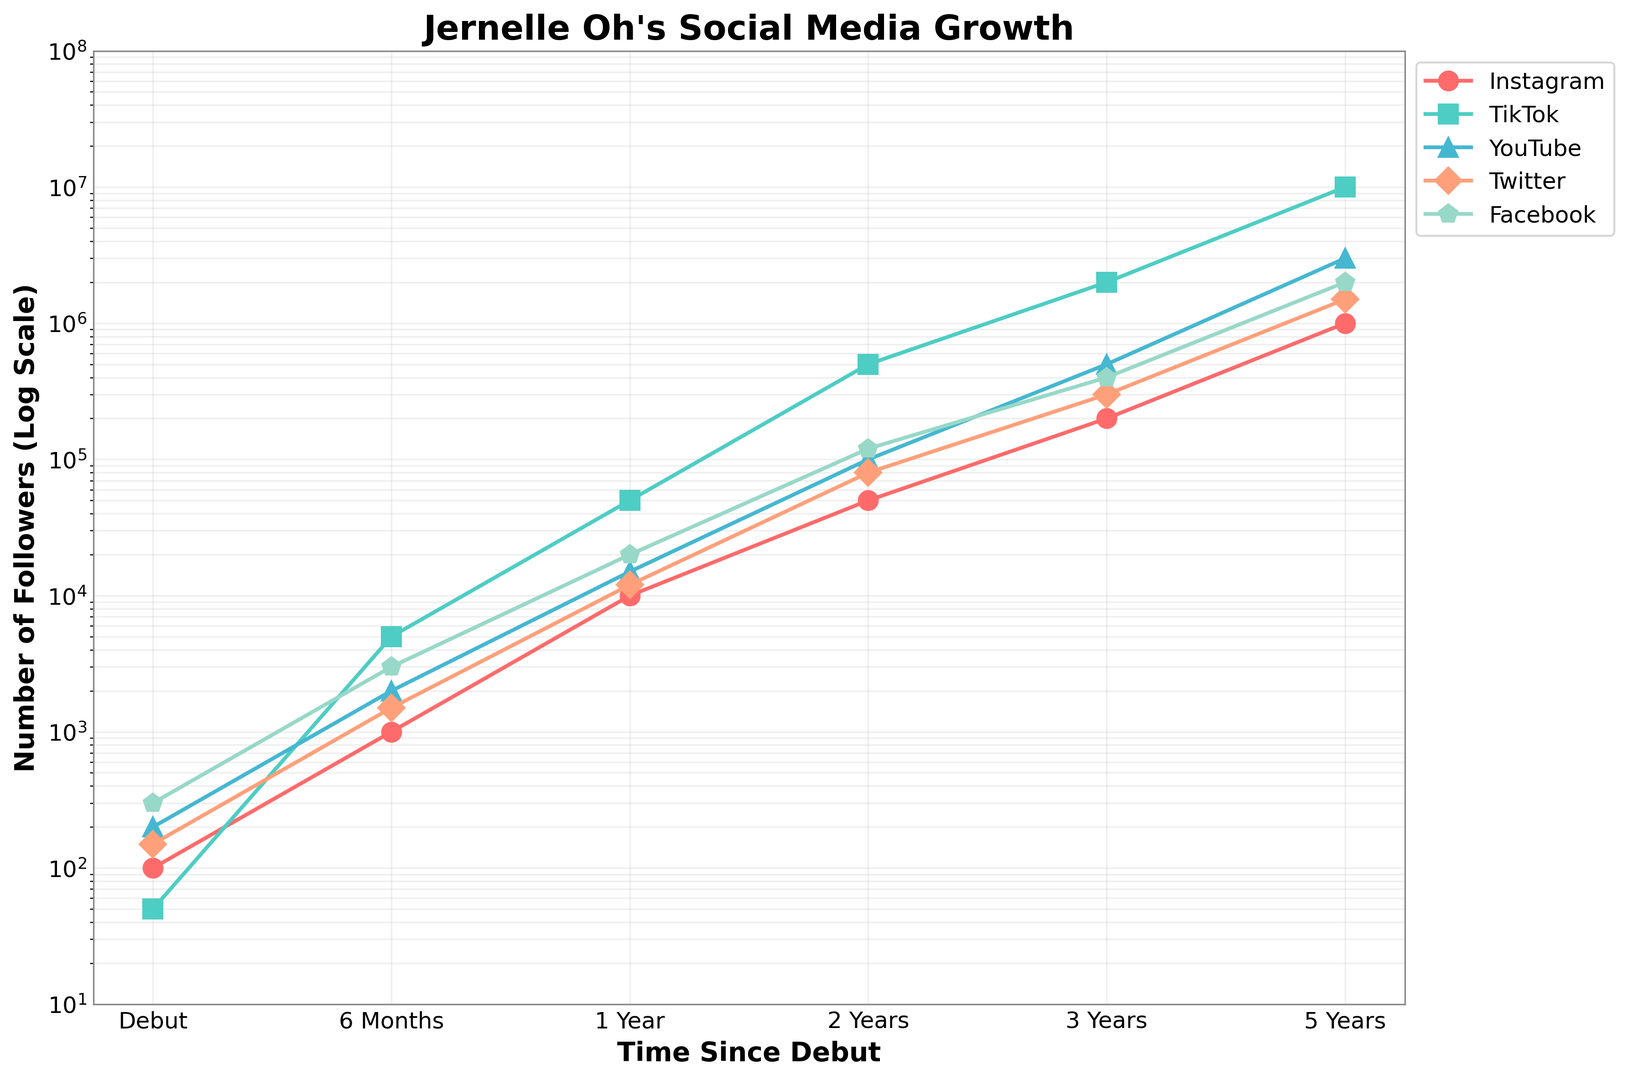what's the platform with the greatest increase in followers from debut to 5 years? To determine the platform with the greatest increase, we need to find the difference in followers between debut and 5 years for each platform. The values are: Instagram (100 to 1,000,000), TikTok (50 to 10,000,000), YouTube (200 to 3,000,000), Twitter (150 to 1,500,000), and Facebook (300 to 2,000,000). TikTok has the largest difference.
Answer: TikTok Which platforms had more than 1,000,000 followers at 3 years? By examining the figure, we can see which platforms have surpassed the 1,000,000 mark at the 3-year time point. TikTok (2,000,000) and Facebook (2,000,000) have more than 1,000,000 followers at 3 years.
Answer: TikTok, Facebook Compare the number of followers for YouTube and Instagram at 1 year. Which one is greater? By looking at the 1-year mark on the chart, YouTube has 15,000 followers and Instagram has 10,000 followers. Therefore, YouTube has more followers at 1 year.
Answer: YouTube Which platform shows the fastest growth rate between 6 months and 1 year? To find the fastest growth rate, we look at the ratio of followers between 6 months and 1 year for each platform. The ratios are: Instagram (1000 to 10,000), TikTok (5000 to 50,000), YouTube (2000 to 15,000), Twitter (1500 to 12,000), and Facebook (3000 to 20,000). TikTok shows the highest growth rate of 10 times.
Answer: TikTok What color represents Facebook in the chart? Each platform is represented by a different color in the chart. By observing the visual attributes, Facebook is shown using the light blue line.
Answer: Light blue What's the average number of followers on Instagram at 6 months and 2 years? To calculate the average number of followers, we add the values at 6 months and 2 years and divide by 2. Instagram has 1,000 followers at 6 months and 50,000 followers at 2 years. The average is (1,000 + 50,000) / 2 = 25,500.
Answer: 25,500 Is the follower count for TikTok more than double that of Instagram at 2 years? TikTok has 500,000 followers at 2 years while Instagram has 50,000 followers. We need to compare 500,000 to 2 * 50,000 = 100,000. 500,000 is indeed more than double 50,000.
Answer: Yes 